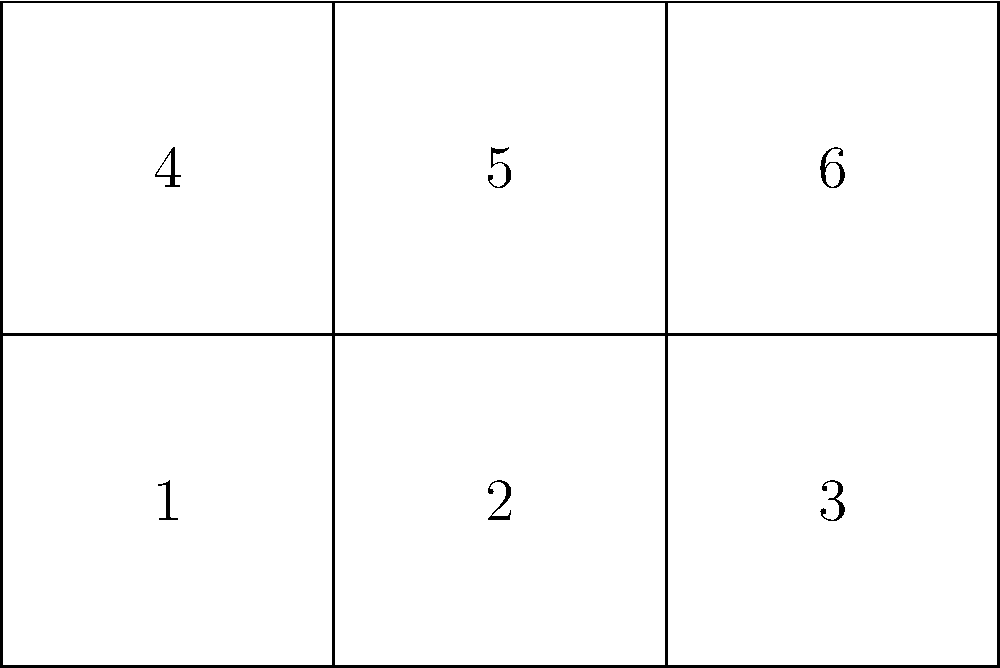The diagram above represents an unfolded paper model of a Masonic temple. When folded correctly, it forms a cube-shaped structure with a symbolic layout. Which face of the cube will be opposite to face 1 when the model is fully assembled? To determine which face will be opposite to face 1 in the assembled cube, we need to mentally fold the template:

1. Face 1 forms the bottom of the cube.
2. Faces 2 and 3 fold up to form the front and right sides, respectively.
3. Face 4 folds up to form the back side.
4. Face 5 folds up to form the left side.
5. Face 6 is the only remaining face, which will fold to form the top of the cube.

In a cube, opposite faces are those that are parallel and do not share any edges. Since face 1 forms the bottom of the cube, its opposite face must be the one that forms the top of the cube.

Therefore, face 6 will be opposite to face 1 when the model is fully assembled.

This layout is significant in Masonic symbolism, as the cube represents perfection and completion. The opposite faces (1 and 6) might represent dualities or complementary concepts in Masonic teachings.
Answer: Face 6 